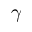<formula> <loc_0><loc_0><loc_500><loc_500>\gamma</formula> 